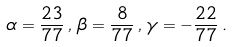<formula> <loc_0><loc_0><loc_500><loc_500>\alpha = \frac { 2 3 } { 7 7 } \, , \, \beta = \frac { 8 } { 7 7 } \, , \, \gamma = - \frac { 2 2 } { 7 7 } \, .</formula> 